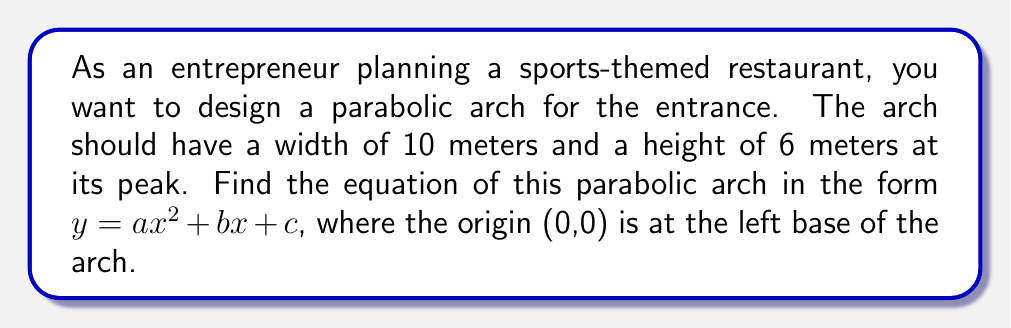Show me your answer to this math problem. Let's approach this step-by-step:

1) The general form of a parabola is $y = ax^2 + bx + c$. We need to find $a$, $b$, and $c$.

2) We know three points on this parabola:
   - Left base: (0, 0)
   - Right base: (10, 0)
   - Vertex (peak): (5, 6)

3) Using the left base point (0, 0):
   $0 = a(0)^2 + b(0) + c$
   $0 = c$
   So, $c = 0$

4) Our equation is now $y = ax^2 + bx$

5) Using the vertex form of a parabola: $y = a(x-h)^2 + k$
   Where (h, k) is the vertex (5, 6)
   $y = a(x-5)^2 + 6$

6) Expanding this:
   $y = a(x^2 - 10x + 25) + 6$
   $y = ax^2 - 10ax + 25a + 6$

7) Comparing with our form $y = ax^2 + bx$:
   $b = -10a$

8) Now, use the right base point (10, 0):
   $0 = a(10)^2 + b(10)$
   $0 = 100a - 100a$
   This is always true, so we need another condition.

9) Use the vertex point (5, 6):
   $6 = a(5)^2 + b(5)$
   $6 = 25a - 50a$
   $6 = -25a$
   $a = -\frac{6}{25} = -0.24$

10) Now we can find $b$:
    $b = -10a = -10(-0.24) = 2.4$

Therefore, the equation of the parabolic arch is $y = -0.24x^2 + 2.4x$.
Answer: $y = -0.24x^2 + 2.4x$ 